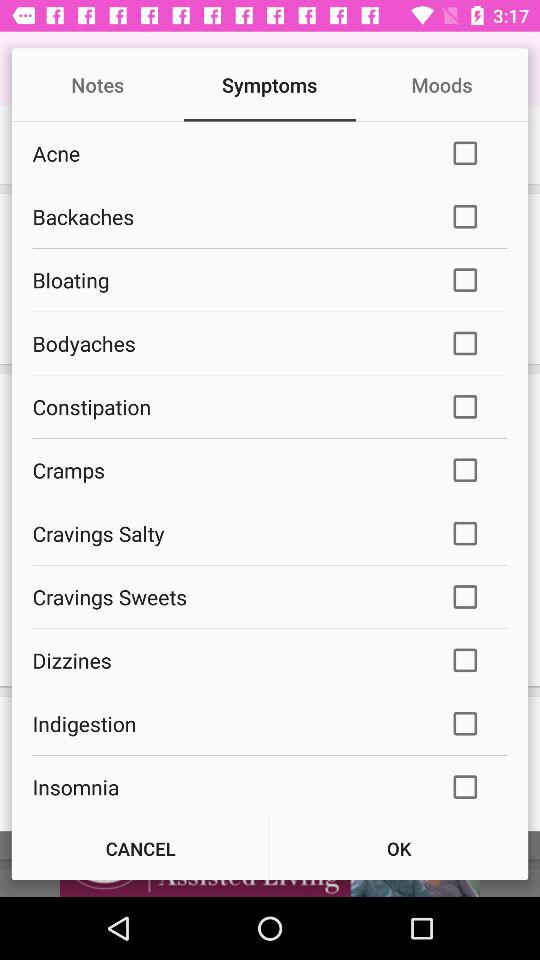What is the status of "Backaches"? The status is "off". 